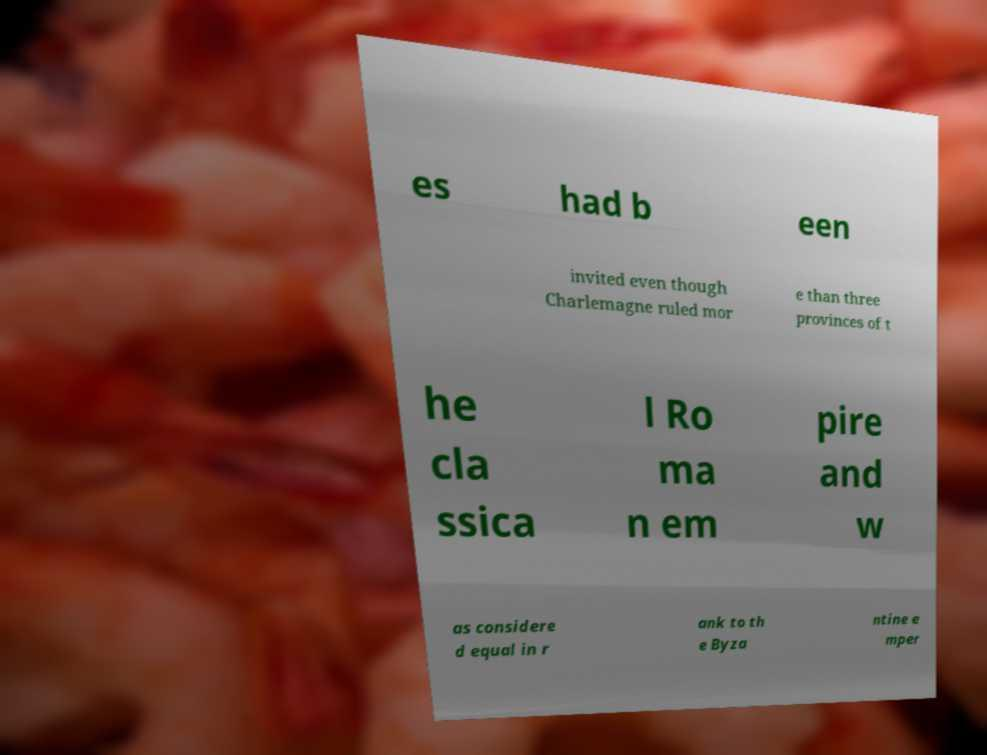Could you assist in decoding the text presented in this image and type it out clearly? es had b een invited even though Charlemagne ruled mor e than three provinces of t he cla ssica l Ro ma n em pire and w as considere d equal in r ank to th e Byza ntine e mper 